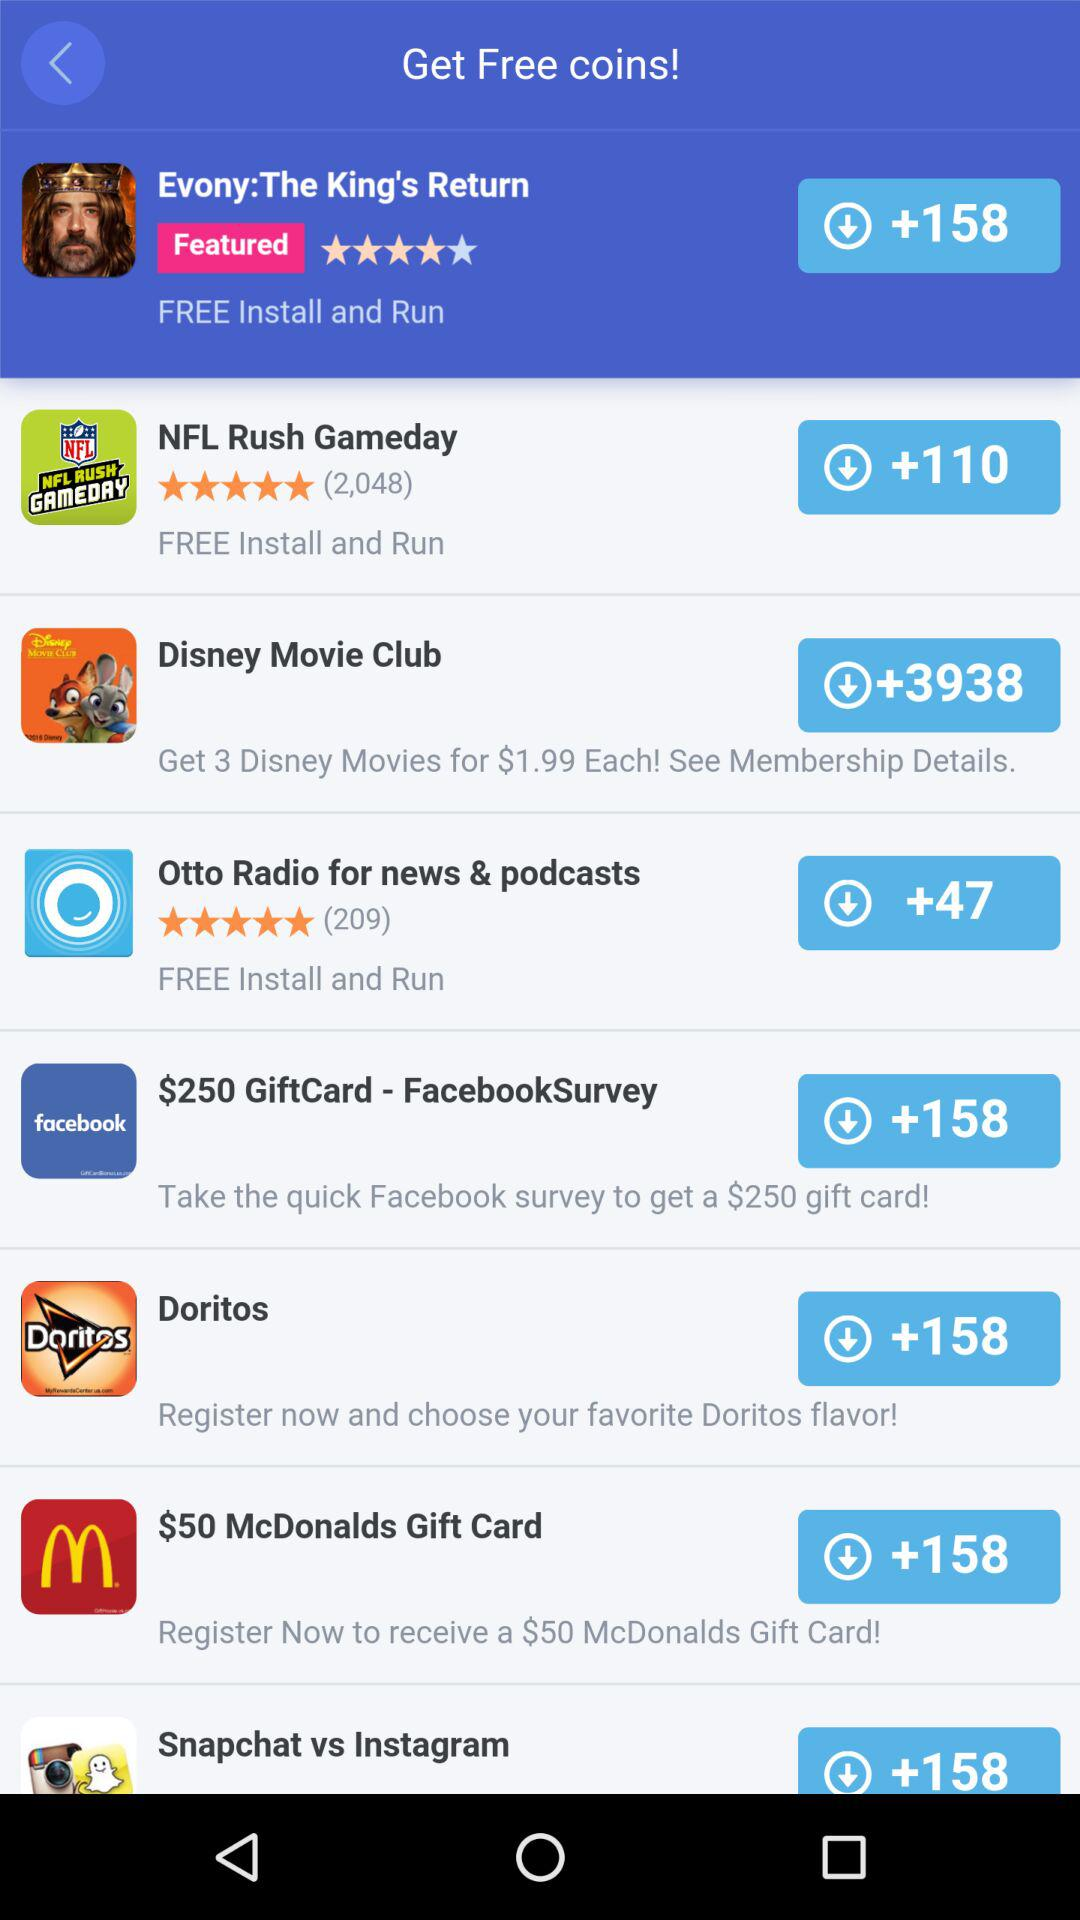What is the price of each Disney movie? The price of each Disney movie is $1.99. 